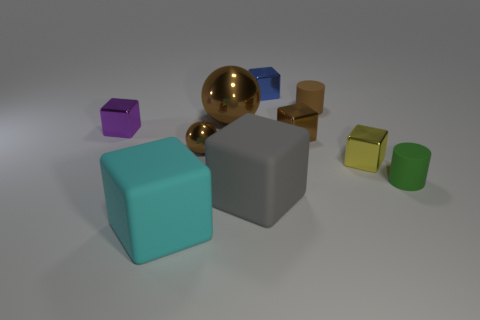There is a tiny ball that is on the right side of the cyan thing that is to the left of the brown rubber thing; how many yellow metal objects are to the left of it?
Your response must be concise. 0. Do the rubber object to the left of the gray matte object and the tiny green object have the same shape?
Your answer should be very brief. No. There is a big thing behind the gray rubber thing; are there any yellow things behind it?
Your response must be concise. No. How many small brown metal things are there?
Your answer should be very brief. 2. What is the color of the big thing that is both on the right side of the cyan rubber object and in front of the small green rubber cylinder?
Ensure brevity in your answer.  Gray. There is a purple object that is the same shape as the big cyan rubber thing; what size is it?
Provide a succinct answer. Small. How many yellow things have the same size as the blue cube?
Provide a short and direct response. 1. What is the green object made of?
Offer a terse response. Rubber. Are there any cubes behind the gray matte cube?
Keep it short and to the point. Yes. The purple thing that is the same material as the small blue block is what size?
Offer a very short reply. Small. 